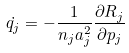<formula> <loc_0><loc_0><loc_500><loc_500>\dot { q _ { j } } = - { { \frac { 1 } { n _ { j } a _ { j } ^ { 2 } } } { \frac { \partial R _ { j } } { \partial p _ { j } } } }</formula> 